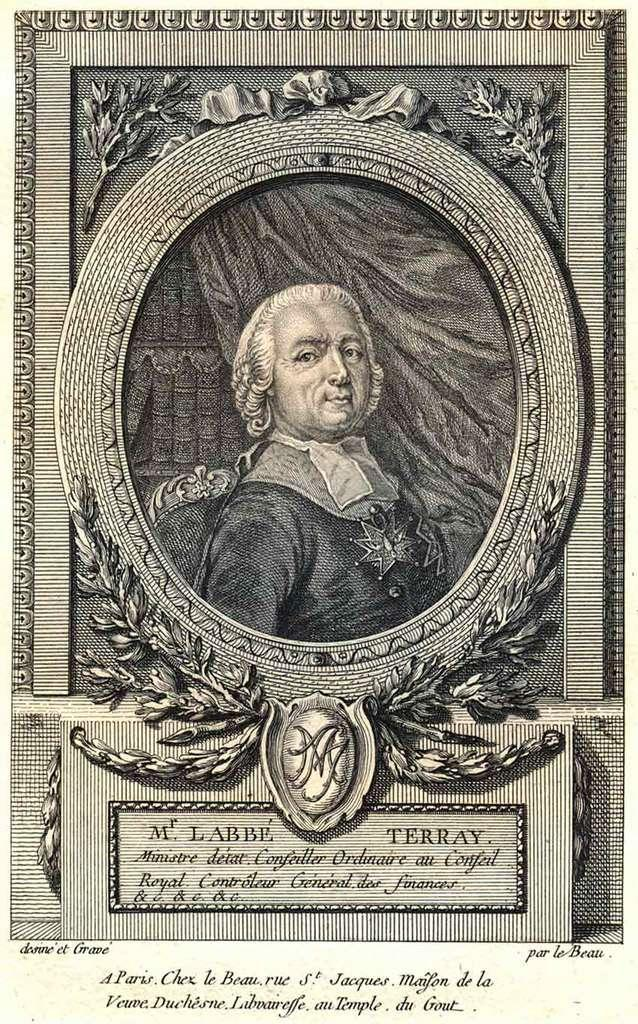<image>
Create a compact narrative representing the image presented. A black and white portrait of a fancy gentleman from the past is captioned with "Mr. Labbe Terray". 